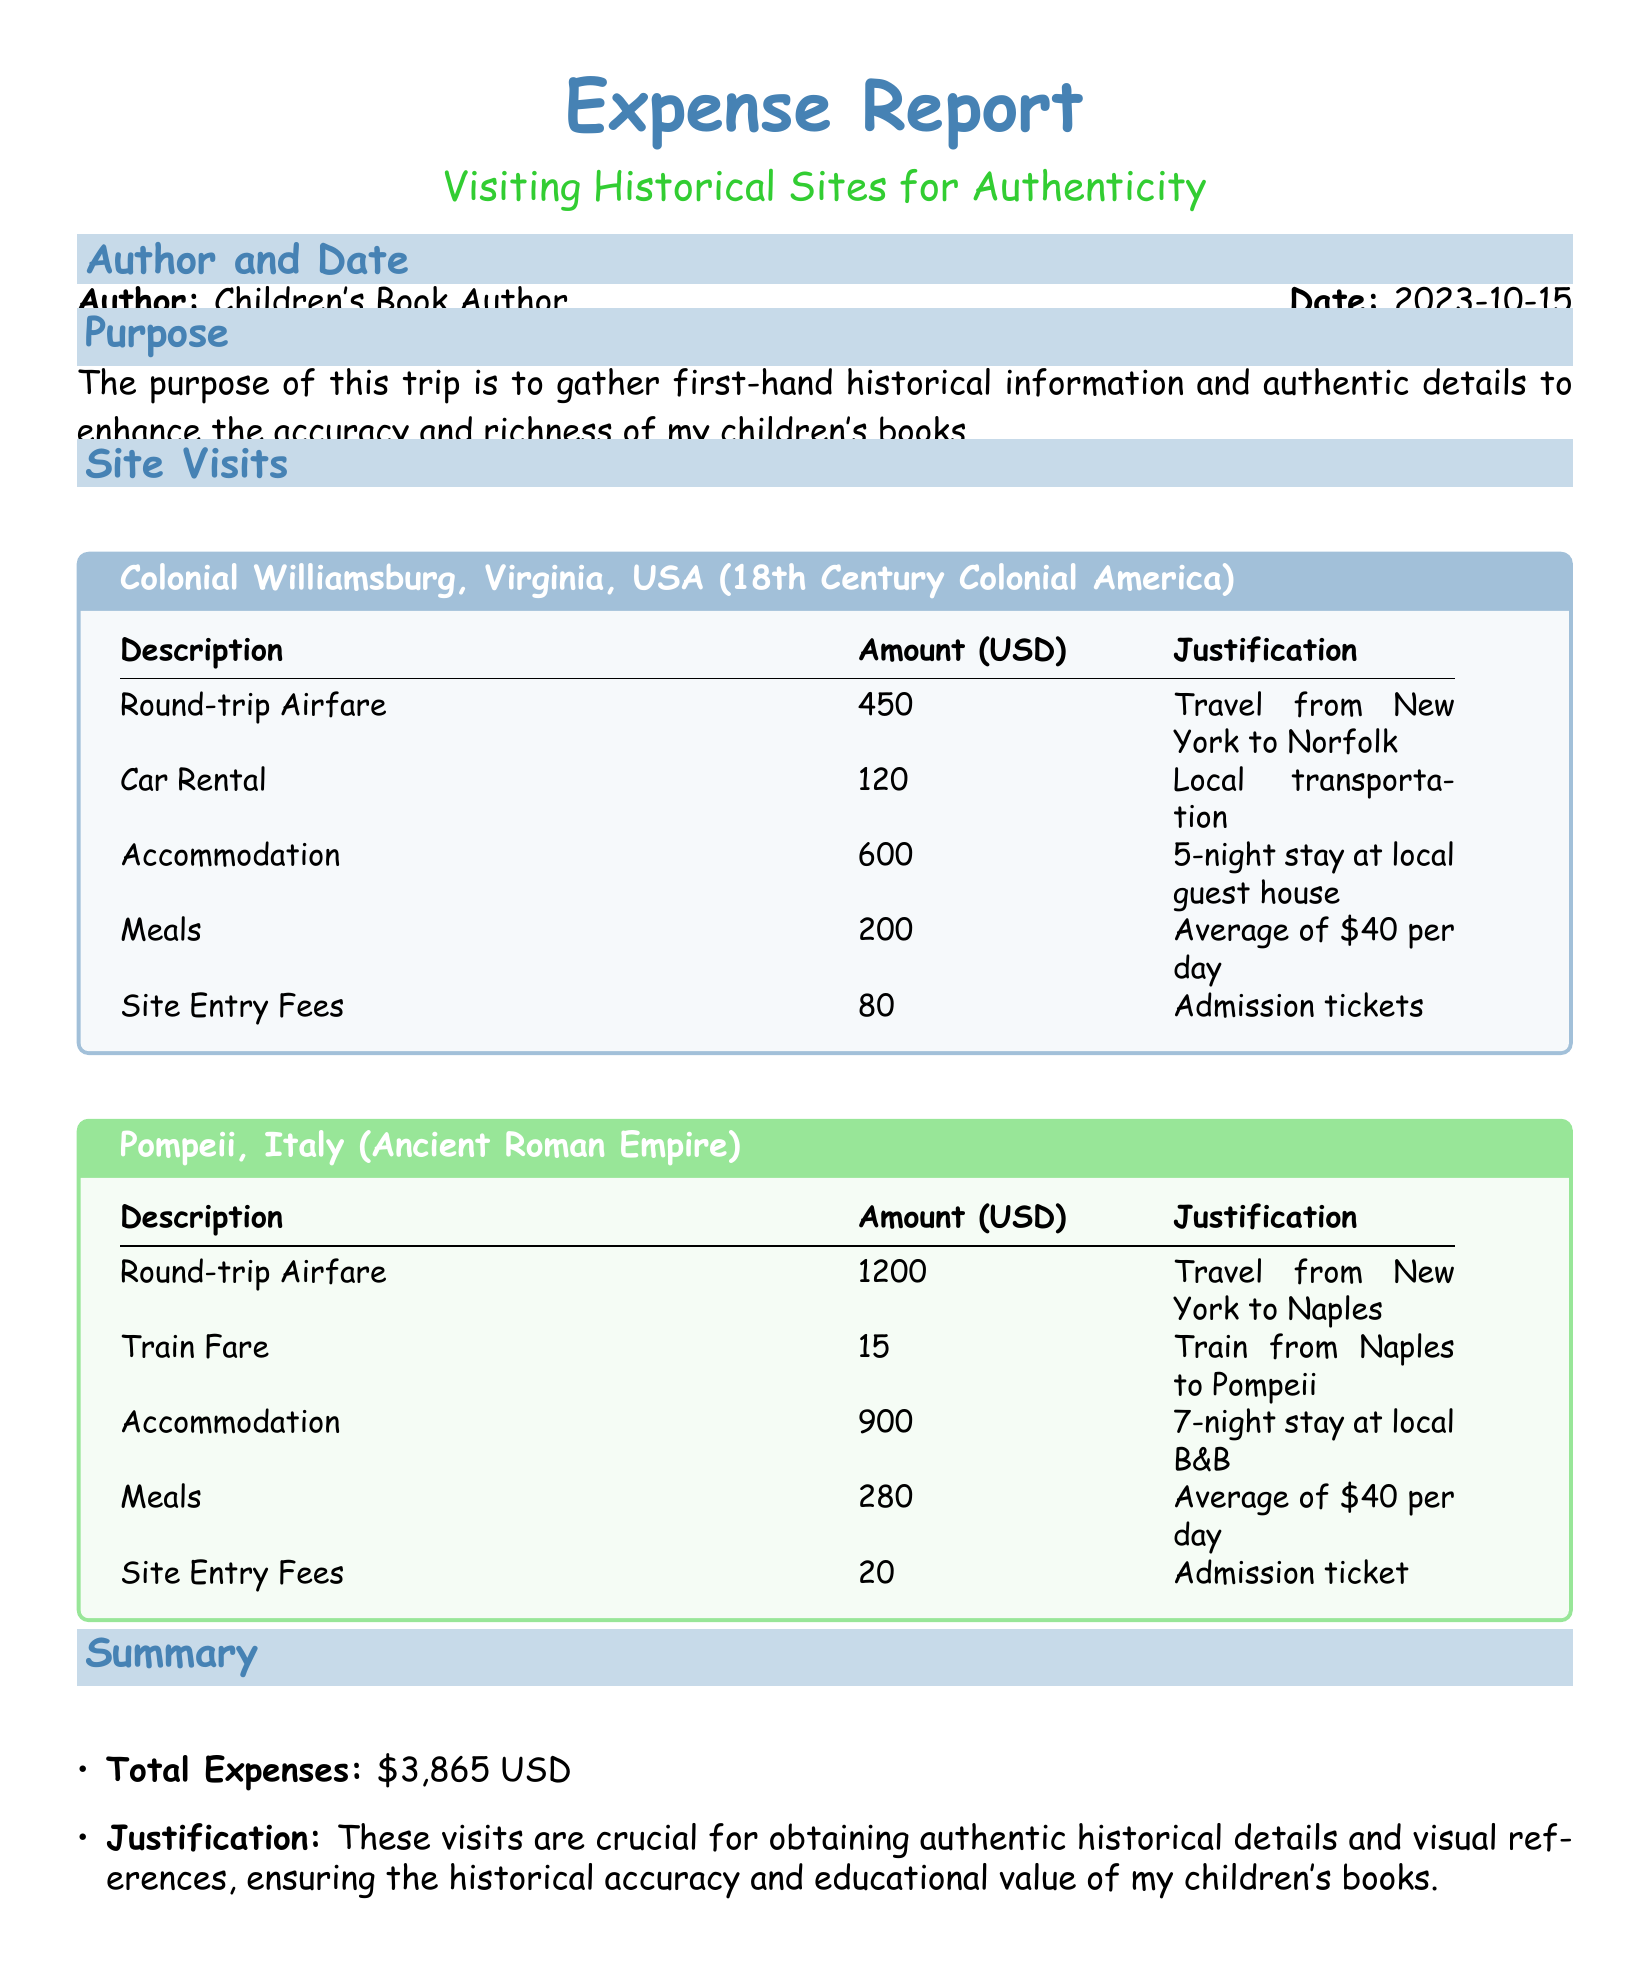What is the total amount spent on meals? The total spent on meals is the sum of meals from both site visits, which is $200 + $280 = $480.
Answer: $480 What is the accommodation cost for Pompeii? The accommodation cost for Pompeii is detailed in the document, showing the figure for a 7-night stay at a local B&B.
Answer: $900 How many nights did the author stay in Colonial Williamsburg? The accommodation cost entry specifies a 5-night stay at a local guest house for the Colonial Williamsburg visit.
Answer: 5 nights What is the purpose of the trip? The document clearly states the purpose as gathering first-hand historical information and authentic details for children's books.
Answer: To enhance historical accuracy What is the site entry fee for Pompeii? The document lists the entry fee specifically for Pompeii as part of the site visit cost breakdown.
Answer: $20 What was the round-trip airfare for Colonial Williamsburg? The airfare for Colonial Williamsburg is detailed in the site visit costs section, showing the specific amount.
Answer: $450 How much was spent on site entry fees in total? The total site entry fees incurred during both visits can be derived from the respective amounts listed separately: $80 + $20.
Answer: $100 What type of transportation was used in Colonial Williamsburg? The type of transportation listed is "Car Rental" for local transportation during the visit to Colonial Williamsburg.
Answer: Car Rental What is the total expense for the trip? The total expenses are summed up from all cost categories including airfare, accommodation, meals, and site entry fees listed in the document.
Answer: $3,865 